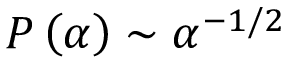<formula> <loc_0><loc_0><loc_500><loc_500>P \left ( \alpha \right ) \sim \alpha ^ { - 1 / 2 }</formula> 